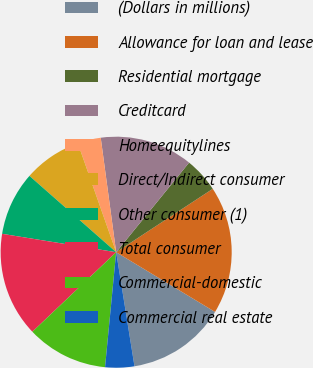Convert chart. <chart><loc_0><loc_0><loc_500><loc_500><pie_chart><fcel>(Dollars in millions)<fcel>Allowance for loan and lease<fcel>Residential mortgage<fcel>Creditcard<fcel>Homeequitylines<fcel>Direct/Indirect consumer<fcel>Other consumer (1)<fcel>Total consumer<fcel>Commercial-domestic<fcel>Commercial real estate<nl><fcel>13.82%<fcel>17.89%<fcel>4.88%<fcel>13.01%<fcel>3.25%<fcel>8.13%<fcel>8.94%<fcel>14.63%<fcel>11.38%<fcel>4.07%<nl></chart> 